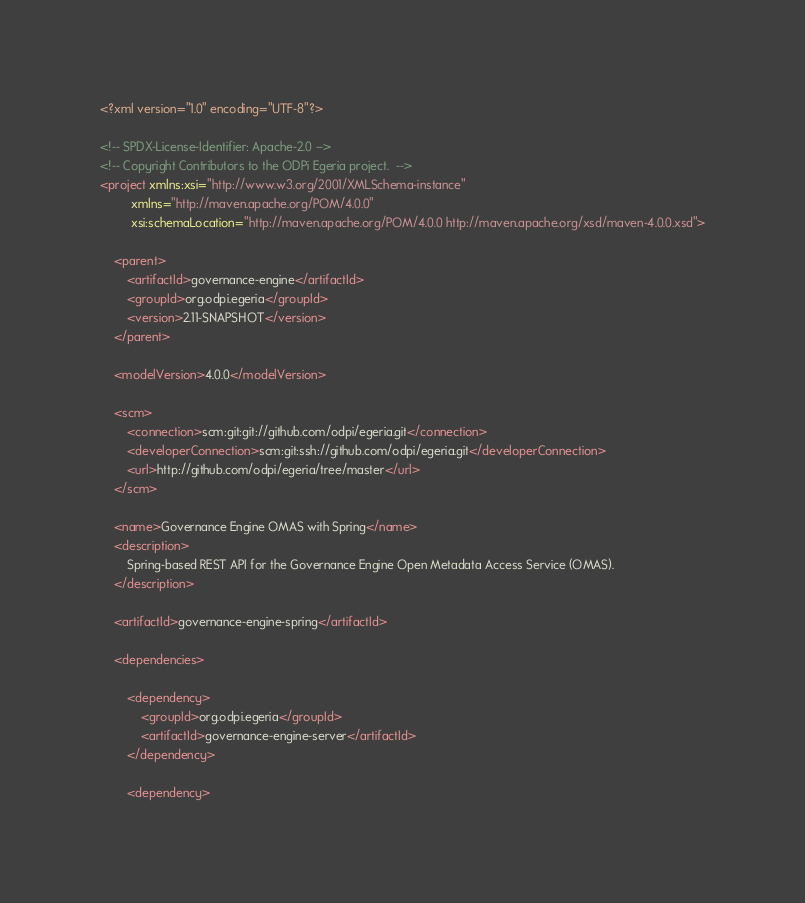<code> <loc_0><loc_0><loc_500><loc_500><_XML_><?xml version="1.0" encoding="UTF-8"?>

<!-- SPDX-License-Identifier: Apache-2.0 -->
<!-- Copyright Contributors to the ODPi Egeria project.  -->
<project xmlns:xsi="http://www.w3.org/2001/XMLSchema-instance"
         xmlns="http://maven.apache.org/POM/4.0.0"
         xsi:schemaLocation="http://maven.apache.org/POM/4.0.0 http://maven.apache.org/xsd/maven-4.0.0.xsd">

    <parent>
        <artifactId>governance-engine</artifactId>
        <groupId>org.odpi.egeria</groupId>
        <version>2.11-SNAPSHOT</version>
    </parent>

    <modelVersion>4.0.0</modelVersion>

    <scm>
        <connection>scm:git:git://github.com/odpi/egeria.git</connection>
        <developerConnection>scm:git:ssh://github.com/odpi/egeria.git</developerConnection>
        <url>http://github.com/odpi/egeria/tree/master</url>
    </scm>

    <name>Governance Engine OMAS with Spring</name>
    <description>
        Spring-based REST API for the Governance Engine Open Metadata Access Service (OMAS).
    </description>

    <artifactId>governance-engine-spring</artifactId>

    <dependencies>

        <dependency>
            <groupId>org.odpi.egeria</groupId>
            <artifactId>governance-engine-server</artifactId>
        </dependency>

        <dependency></code> 